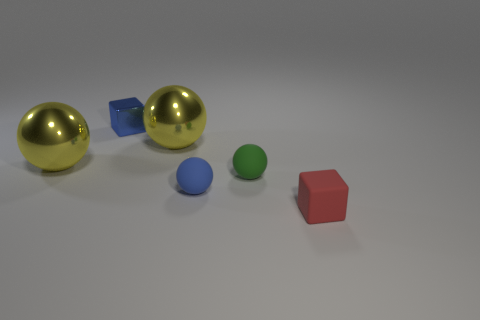Add 2 green rubber cylinders. How many objects exist? 8 Subtract all yellow spheres. How many spheres are left? 2 Subtract all cubes. How many objects are left? 4 Add 6 small shiny blocks. How many small shiny blocks exist? 7 Subtract 1 green spheres. How many objects are left? 5 Subtract 2 balls. How many balls are left? 2 Subtract all green cubes. Subtract all gray spheres. How many cubes are left? 2 Subtract all green blocks. How many brown balls are left? 0 Subtract all blue balls. Subtract all rubber spheres. How many objects are left? 3 Add 1 red matte cubes. How many red matte cubes are left? 2 